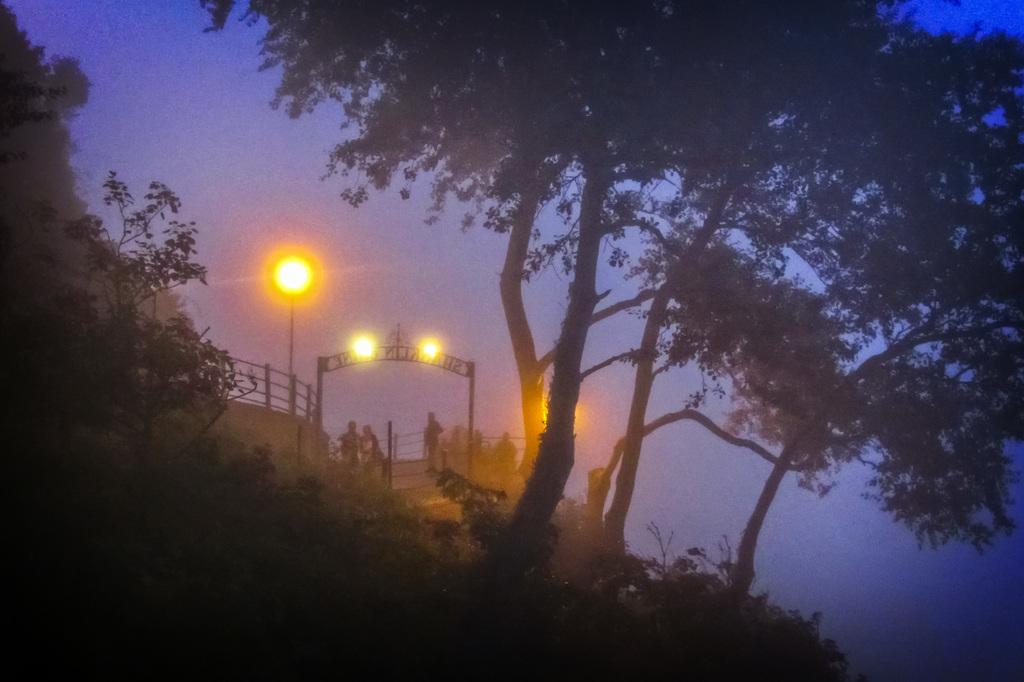What type of natural elements can be seen in the image? There are trees in the image. What type of structure is present in the image? There is an arch in the image. What type of material is used for the grilles in the image? There are iron grilles in the image. Are there any human subjects in the image? Yes, there are people in the image. What type of artificial lighting is present in the image? There are street lights in the image. Can you describe the lipstick shade worn by the person in the image? There are no references to lipstick or any cosmetic products in the image. Is there a fight taking place in the image? There is no indication of a fight or any conflict in the image. 